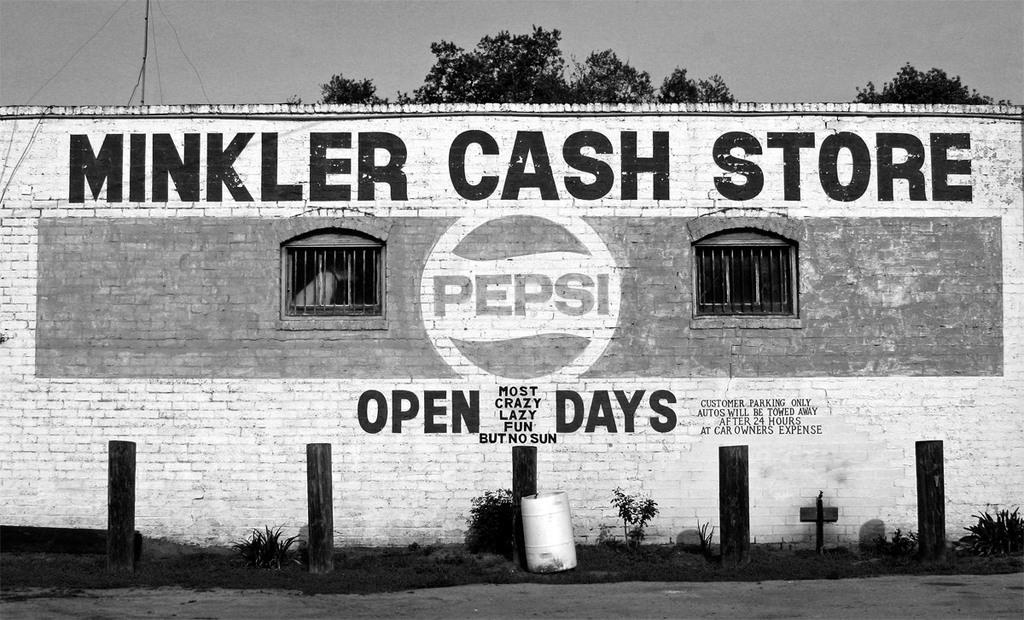In one or two sentences, can you explain what this image depicts? In this image in front there are wooden poles. There is a can. There are plants. In the background of the image there is a wall with some text on it. There are windows. There are trees and sky. 